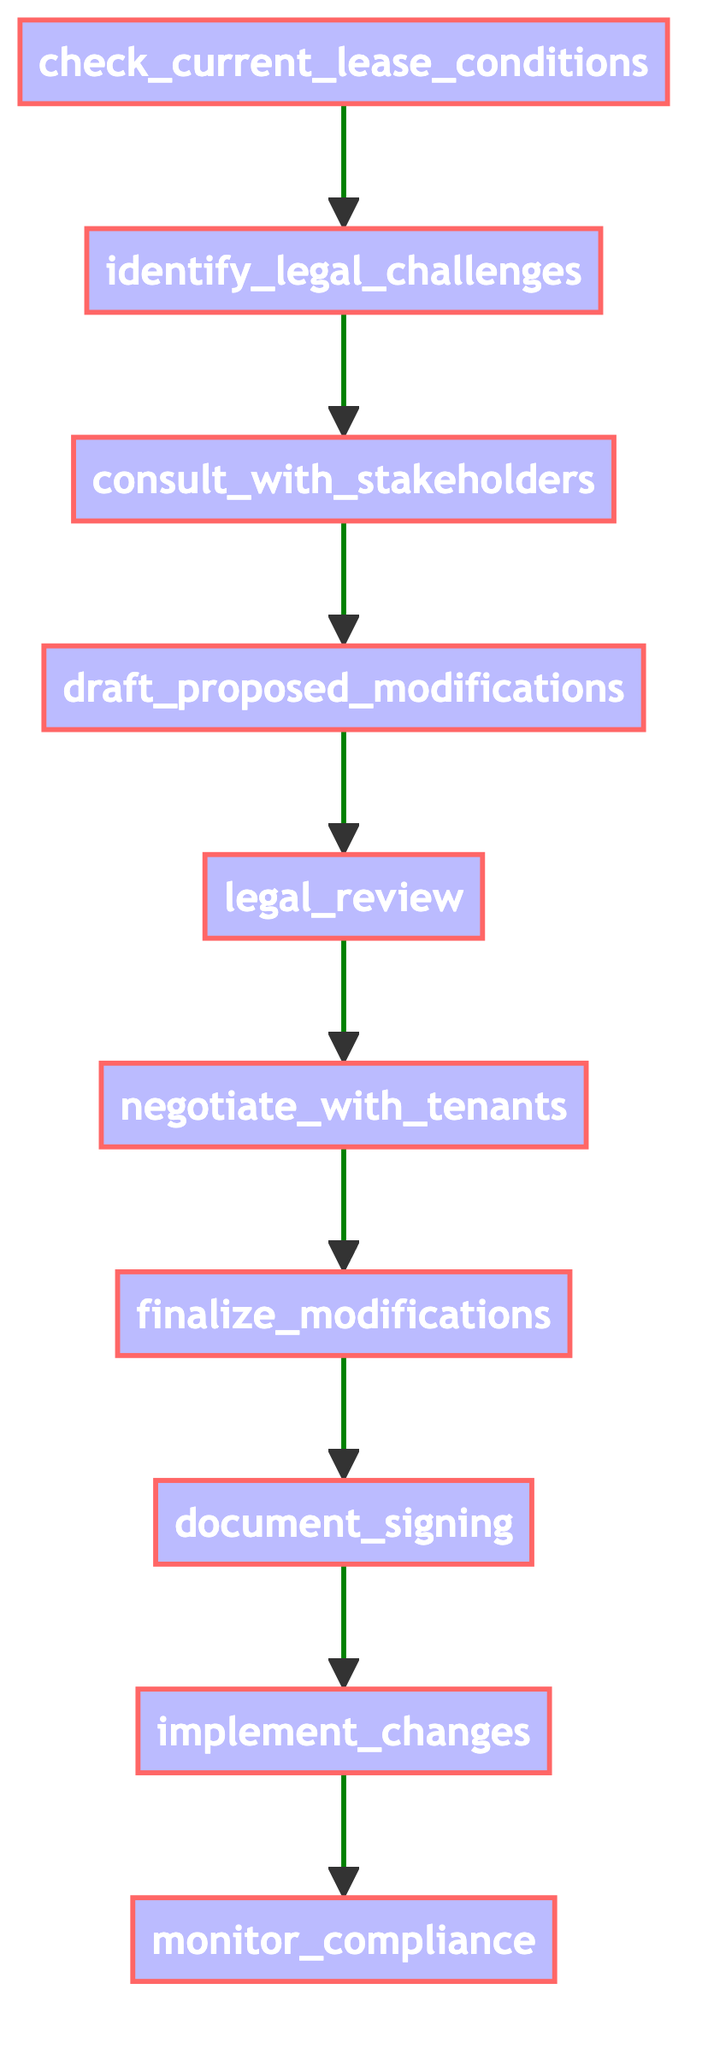What is the first step in the process? The diagram starts with the node "check_current_lease_conditions," which is the first step in the flowchart.
Answer: check current lease conditions How many total steps are there in the flowchart? By counting all the nodes listed in the flowchart, there are ten distinct steps from "check_current_lease_conditions" to "monitor_compliance."
Answer: ten Which step directly follows "legal_review"? The step that follows "legal_review" is "negotiate_with_tenants," as per the flow of the diagram.
Answer: negotiate with tenants What process checks for compliance with new lease terms? The final step in the diagram is "monitor_compliance," which involves checking for adherence to the new lease terms.
Answer: monitor compliance Are stakeholders consulted before drafting modifications? Yes, "consult_with_stakeholders" comes before "draft_proposed_modifications," meaning stakeholders are consulted first.
Answer: Yes What is the relationship between "finalize_modifications" and "document_signing"? "Finalize_modifications" is a prerequisite to "document_signing"; the modifications need to be finalized before signing can occur.
Answer: Finalize modifications before document signing How many modifications are required before executing "implement_changes"? According to the flowchart, all prior steps, including legal review and negotiations, must be completed first before implementing changes, which implies the modifications themselves must be finalized first.
Answer: One Which step would involve discussions with tenants? "Negotiate_with_tenants" is specifically where discussions with tenants occur regarding the proposed lease modifications.
Answer: negotiate with tenants What follows the implementation of the lease changes? After "implement_changes," the next step is "monitor_compliance," indicating ongoing oversight after the changes are made.
Answer: monitor compliance 